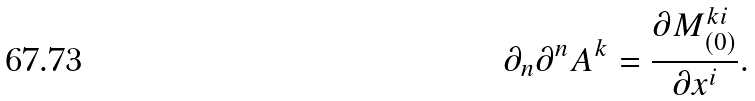Convert formula to latex. <formula><loc_0><loc_0><loc_500><loc_500>\partial _ { n } \partial ^ { n } A ^ { k } = \frac { \partial M ^ { k i } _ { ( 0 ) } } { \partial x ^ { i } } .</formula> 